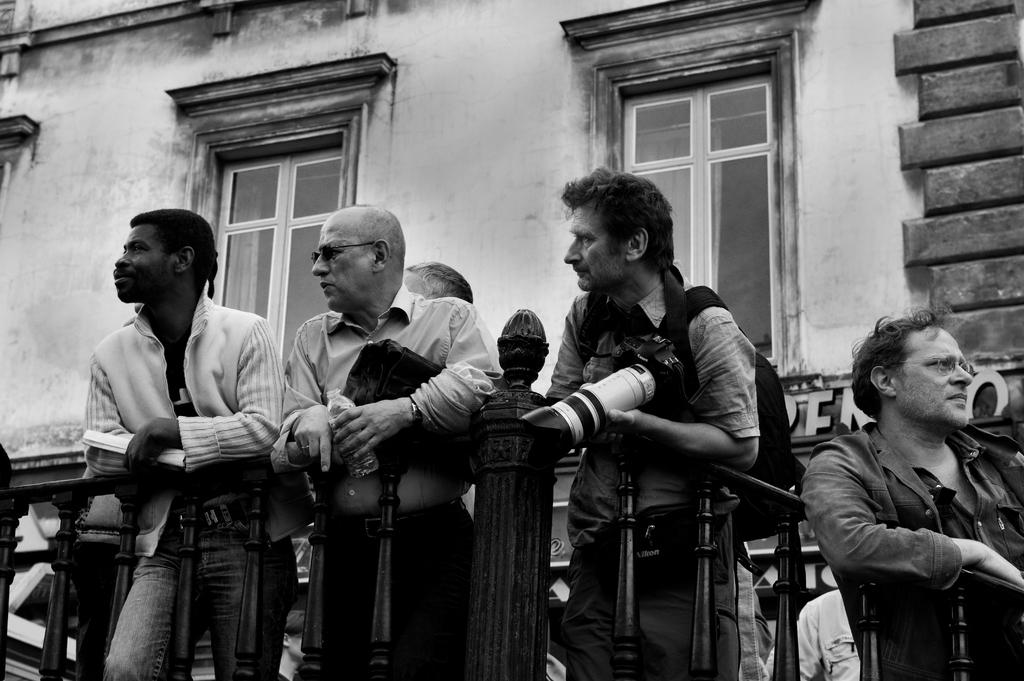What is happening in the image? There are persons standing in the image. What can be seen near the persons? There is a railing in the image. What is visible in the background of the image? There are two windows and a wall visible in the background of the image. What type of soup is being served in the image? There is no soup present in the image. How many pets can be seen in the image? There are no pets visible in the image. 